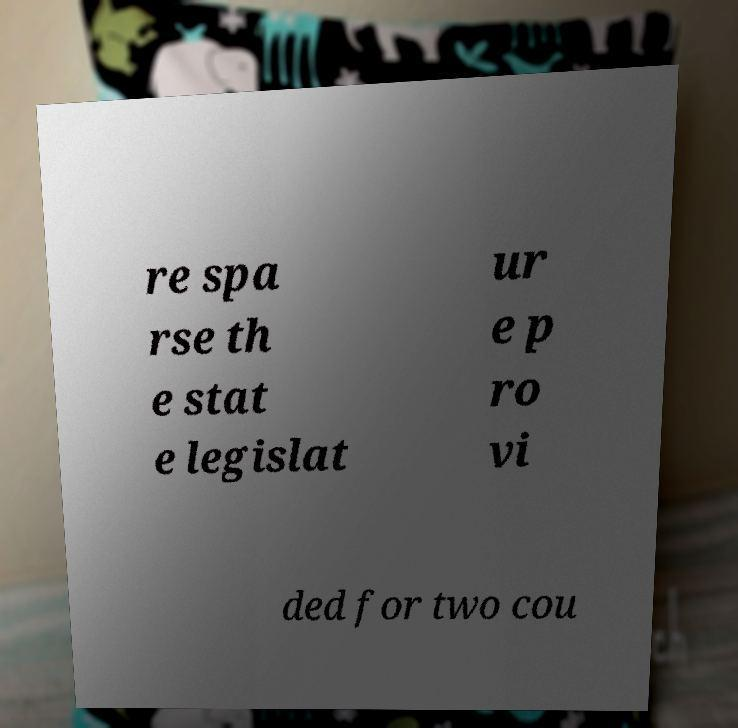I need the written content from this picture converted into text. Can you do that? re spa rse th e stat e legislat ur e p ro vi ded for two cou 